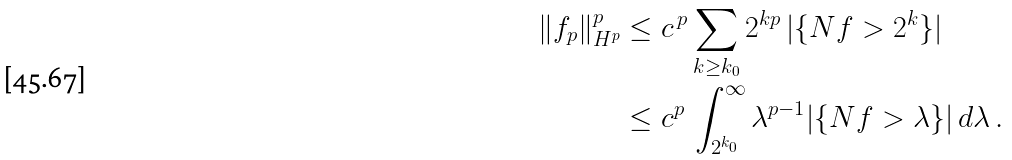<formula> <loc_0><loc_0><loc_500><loc_500>\| f _ { p } \| ^ { p } _ { H ^ { p } } & \leq c ^ { \, p } \sum _ { k \geq k _ { 0 } } 2 ^ { k p } \, | \{ N f > 2 ^ { k } \} | \\ & \leq c ^ { p } \, \int _ { 2 ^ { k _ { 0 } } } ^ { \infty } \lambda ^ { p - 1 } | \{ N f > \lambda \} | \, d \lambda \, .</formula> 